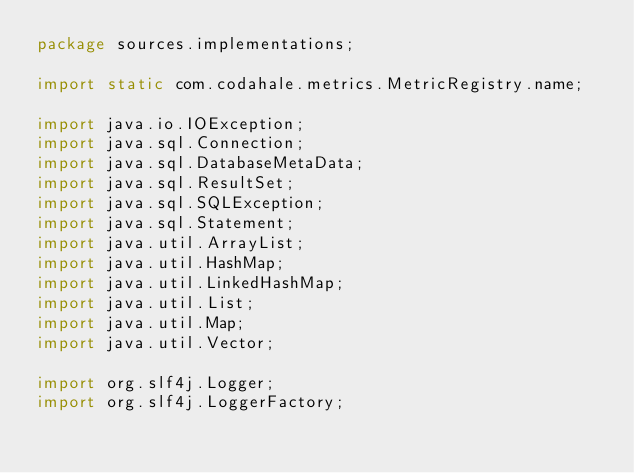Convert code to text. <code><loc_0><loc_0><loc_500><loc_500><_Java_>package sources.implementations;

import static com.codahale.metrics.MetricRegistry.name;

import java.io.IOException;
import java.sql.Connection;
import java.sql.DatabaseMetaData;
import java.sql.ResultSet;
import java.sql.SQLException;
import java.sql.Statement;
import java.util.ArrayList;
import java.util.HashMap;
import java.util.LinkedHashMap;
import java.util.List;
import java.util.Map;
import java.util.Vector;

import org.slf4j.Logger;
import org.slf4j.LoggerFactory;
</code> 